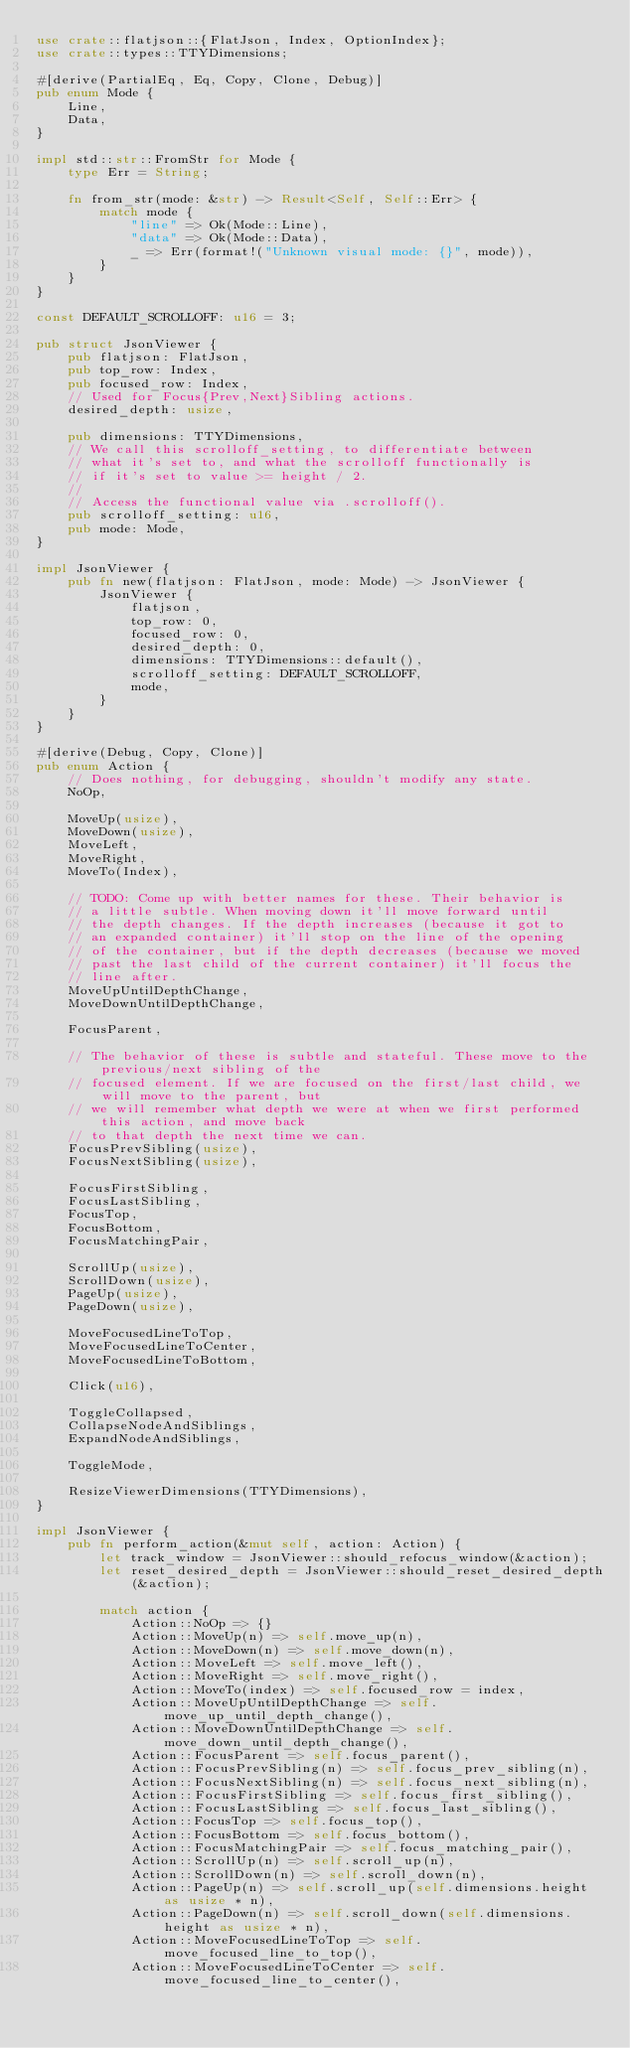<code> <loc_0><loc_0><loc_500><loc_500><_Rust_>use crate::flatjson::{FlatJson, Index, OptionIndex};
use crate::types::TTYDimensions;

#[derive(PartialEq, Eq, Copy, Clone, Debug)]
pub enum Mode {
    Line,
    Data,
}

impl std::str::FromStr for Mode {
    type Err = String;

    fn from_str(mode: &str) -> Result<Self, Self::Err> {
        match mode {
            "line" => Ok(Mode::Line),
            "data" => Ok(Mode::Data),
            _ => Err(format!("Unknown visual mode: {}", mode)),
        }
    }
}

const DEFAULT_SCROLLOFF: u16 = 3;

pub struct JsonViewer {
    pub flatjson: FlatJson,
    pub top_row: Index,
    pub focused_row: Index,
    // Used for Focus{Prev,Next}Sibling actions.
    desired_depth: usize,

    pub dimensions: TTYDimensions,
    // We call this scrolloff_setting, to differentiate between
    // what it's set to, and what the scrolloff functionally is
    // if it's set to value >= height / 2.
    //
    // Access the functional value via .scrolloff().
    pub scrolloff_setting: u16,
    pub mode: Mode,
}

impl JsonViewer {
    pub fn new(flatjson: FlatJson, mode: Mode) -> JsonViewer {
        JsonViewer {
            flatjson,
            top_row: 0,
            focused_row: 0,
            desired_depth: 0,
            dimensions: TTYDimensions::default(),
            scrolloff_setting: DEFAULT_SCROLLOFF,
            mode,
        }
    }
}

#[derive(Debug, Copy, Clone)]
pub enum Action {
    // Does nothing, for debugging, shouldn't modify any state.
    NoOp,

    MoveUp(usize),
    MoveDown(usize),
    MoveLeft,
    MoveRight,
    MoveTo(Index),

    // TODO: Come up with better names for these. Their behavior is
    // a little subtle. When moving down it'll move forward until
    // the depth changes. If the depth increases (because it got to
    // an expanded container) it'll stop on the line of the opening
    // of the container, but if the depth decreases (because we moved
    // past the last child of the current container) it'll focus the
    // line after.
    MoveUpUntilDepthChange,
    MoveDownUntilDepthChange,

    FocusParent,

    // The behavior of these is subtle and stateful. These move to the previous/next sibling of the
    // focused element. If we are focused on the first/last child, we will move to the parent, but
    // we will remember what depth we were at when we first performed this action, and move back
    // to that depth the next time we can.
    FocusPrevSibling(usize),
    FocusNextSibling(usize),

    FocusFirstSibling,
    FocusLastSibling,
    FocusTop,
    FocusBottom,
    FocusMatchingPair,

    ScrollUp(usize),
    ScrollDown(usize),
    PageUp(usize),
    PageDown(usize),

    MoveFocusedLineToTop,
    MoveFocusedLineToCenter,
    MoveFocusedLineToBottom,

    Click(u16),

    ToggleCollapsed,
    CollapseNodeAndSiblings,
    ExpandNodeAndSiblings,

    ToggleMode,

    ResizeViewerDimensions(TTYDimensions),
}

impl JsonViewer {
    pub fn perform_action(&mut self, action: Action) {
        let track_window = JsonViewer::should_refocus_window(&action);
        let reset_desired_depth = JsonViewer::should_reset_desired_depth(&action);

        match action {
            Action::NoOp => {}
            Action::MoveUp(n) => self.move_up(n),
            Action::MoveDown(n) => self.move_down(n),
            Action::MoveLeft => self.move_left(),
            Action::MoveRight => self.move_right(),
            Action::MoveTo(index) => self.focused_row = index,
            Action::MoveUpUntilDepthChange => self.move_up_until_depth_change(),
            Action::MoveDownUntilDepthChange => self.move_down_until_depth_change(),
            Action::FocusParent => self.focus_parent(),
            Action::FocusPrevSibling(n) => self.focus_prev_sibling(n),
            Action::FocusNextSibling(n) => self.focus_next_sibling(n),
            Action::FocusFirstSibling => self.focus_first_sibling(),
            Action::FocusLastSibling => self.focus_last_sibling(),
            Action::FocusTop => self.focus_top(),
            Action::FocusBottom => self.focus_bottom(),
            Action::FocusMatchingPair => self.focus_matching_pair(),
            Action::ScrollUp(n) => self.scroll_up(n),
            Action::ScrollDown(n) => self.scroll_down(n),
            Action::PageUp(n) => self.scroll_up(self.dimensions.height as usize * n),
            Action::PageDown(n) => self.scroll_down(self.dimensions.height as usize * n),
            Action::MoveFocusedLineToTop => self.move_focused_line_to_top(),
            Action::MoveFocusedLineToCenter => self.move_focused_line_to_center(),</code> 